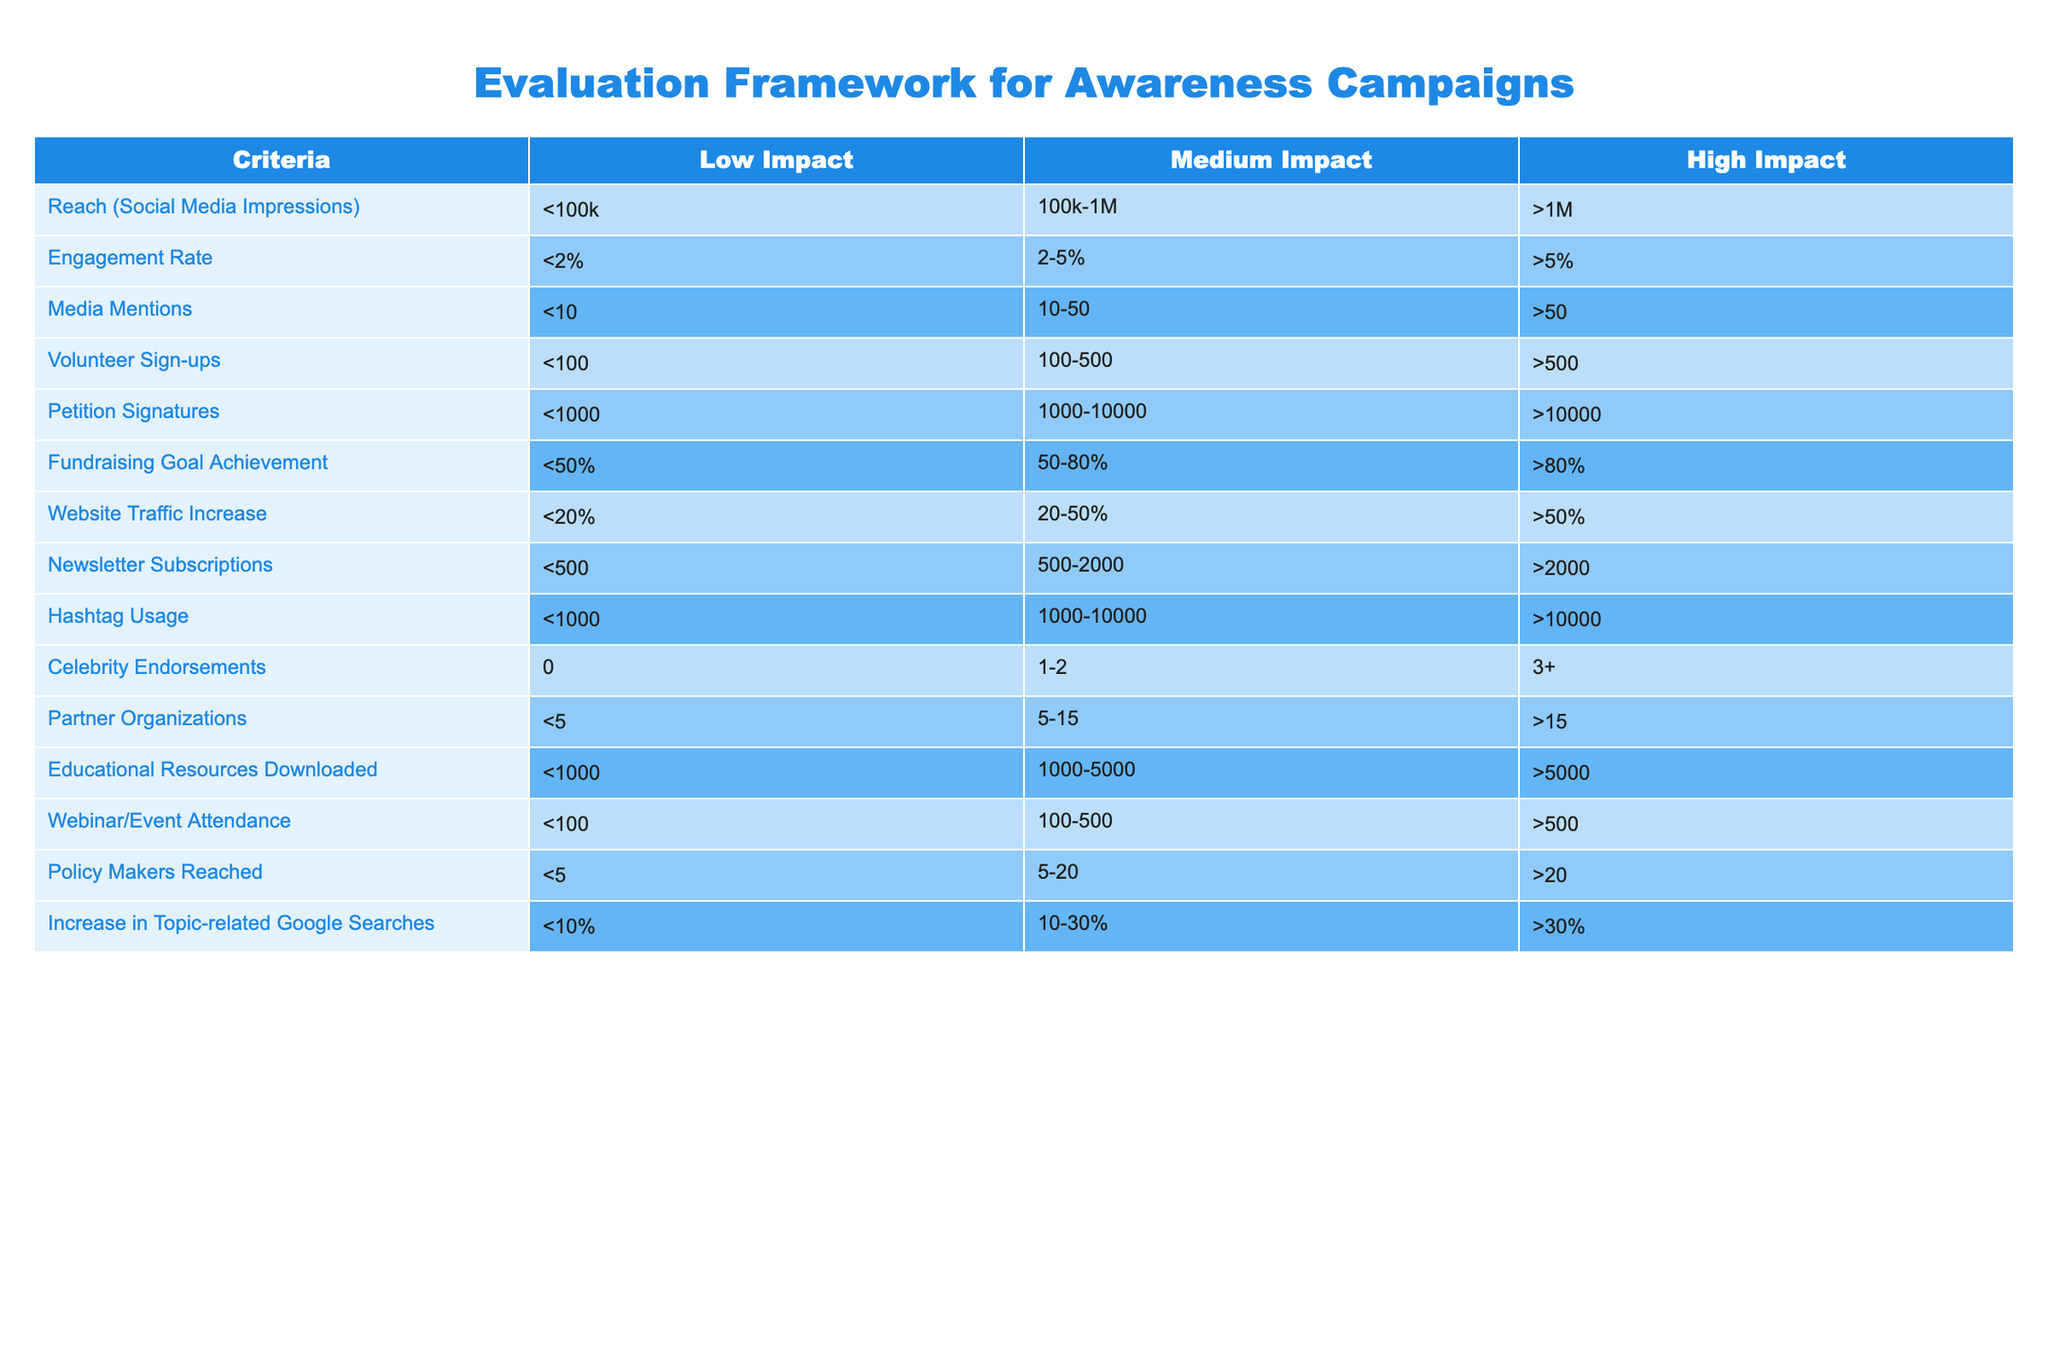What is the reach category for campaigns with over 1 million social media impressions? The table shows that the reach category for campaigns with over 1 million social media impressions falls under "High Impact."
Answer: High Impact How many media mentions correspond to a medium impact level? The table indicates that a medium impact level for media mentions is categorized as between 10 to 50 mentions.
Answer: 10-50 If a campaign achieved a fundraising goal of 75%, what impact level does that category fall into? According to the table, a fundraising goal achievement of 75% falls into the "Medium Impact" category, which includes values between 50% and 80%.
Answer: Medium Impact What is the minimum number of volunteer sign-ups needed to qualify for a high impact rating? The table specifies that the minimum number of volunteer sign-ups needed for a high impact rating is greater than 500.
Answer: >500 Are the number of hashtags used greater than 10,000 considered high impact? Yes, the table confirms that using more than 10,000 hashtags is categorized as "High Impact."
Answer: Yes How does the engagement rate of 3% compare across impact categories? A 3% engagement rate falls in the medium impact category (2-5%), while anything below 2% is low impact and over 5% is high impact. Therefore, 3% signifies a medium impact.
Answer: Medium Impact What is the total number of partner organizations at the low impact level? The table lists that at the low impact level, the number of partner organizations is less than 5.
Answer: <5 If campaign X has 250 newsletter subscriptions, what is its impact rating? According to the table, 250 newsletter subscriptions categorize the campaign at the low impact level, which is below the range for medium impact (500-2000).
Answer: Low Impact What is the difference between the high impact numbers of petition signatures and volunteer sign-ups? For high impact, petition signatures must exceed 10,000 and volunteer sign-ups must exceed 500. The difference is 10,000 - 500, which equals 9,500.
Answer: 9,500 